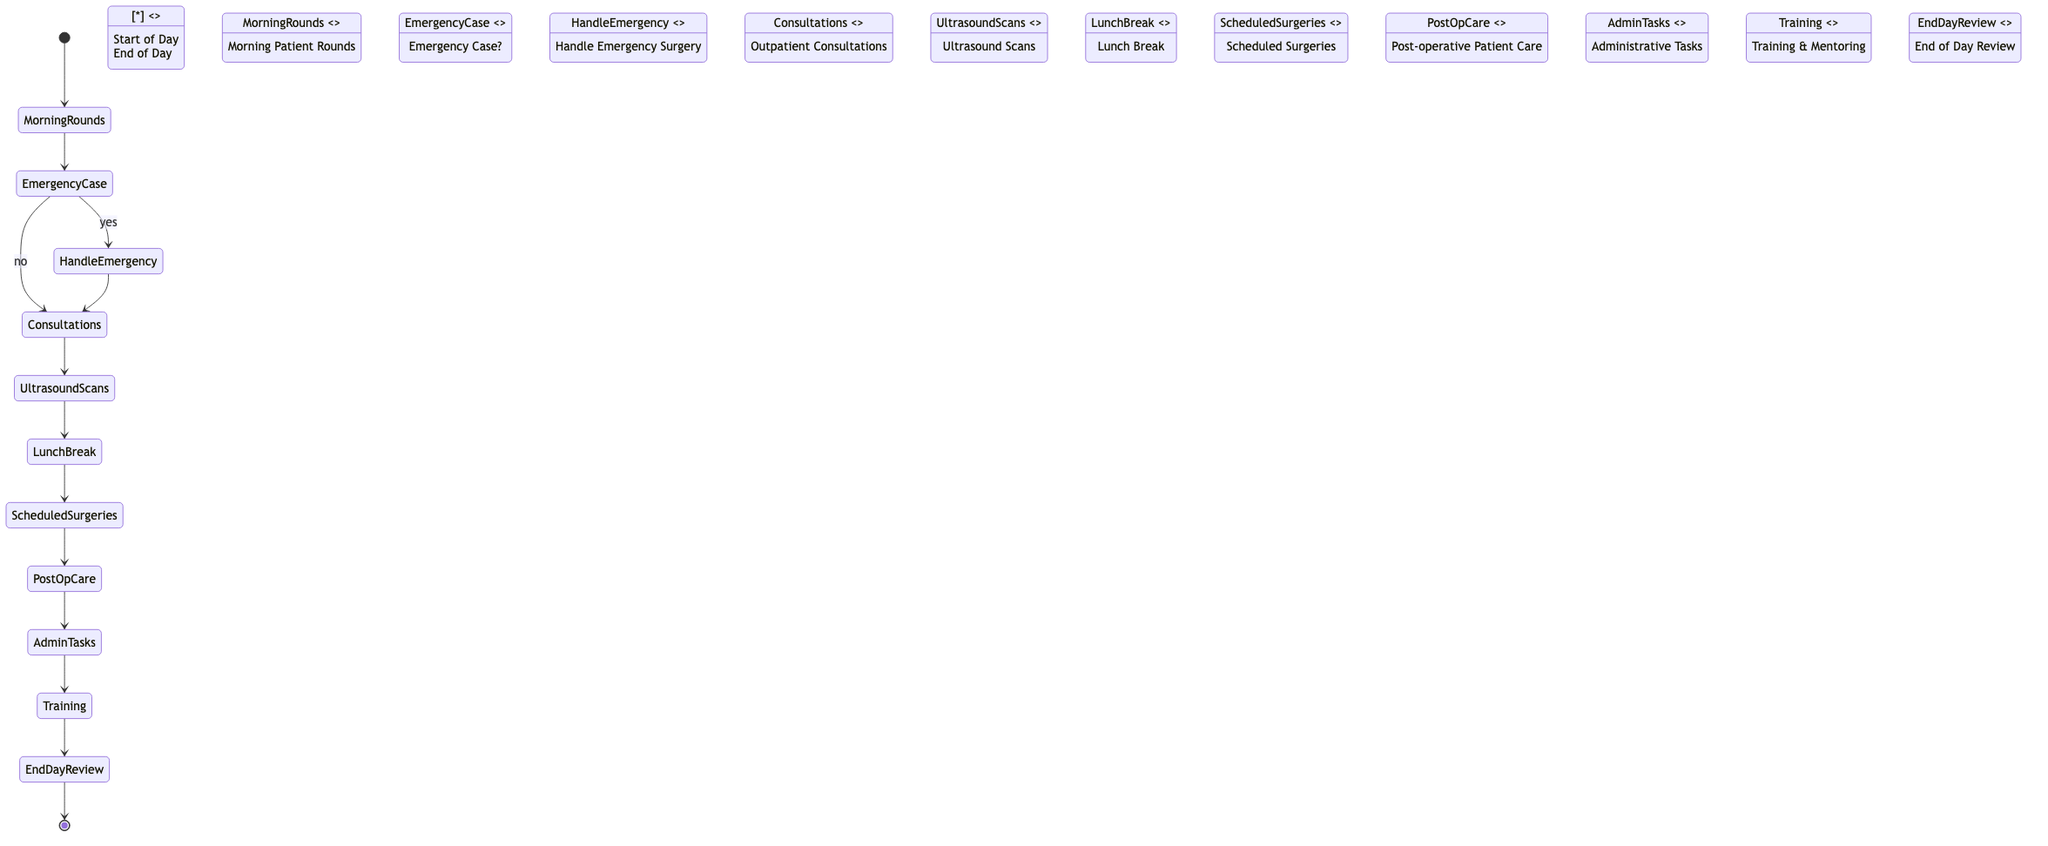What is the first activity in the daily workflow? The first activity is "Morning Patient Rounds," which follows the initial node labeled "Start of Day."
Answer: Morning Patient Rounds How many decision nodes are present in the diagram? There is one decision node labeled "Emergency Case?" that leads to different paths based on the condition.
Answer: 1 What comes after "Lunch Break"? After "Lunch Break," the next activity is "Scheduled Surgeries," as indicated by the flow from one activity to the next.
Answer: Scheduled Surgeries What activity follows "Post-operative Patient Care"? "Administrative Tasks" comes next after "Post-operative Patient Care" in the workflow sequence.
Answer: Administrative Tasks What happens if there is an "Emergency Case"? If there is an "Emergency Case," the workflow path goes to "Handle Emergency Surgery." This is determined by the condition of the decision node.
Answer: Handle Emergency Surgery Which activity occurs after "Scheduled Surgeries"? The activity that occurs after "Scheduled Surgeries" is "Post-operative Patient Care." This follows the flow established in the diagram.
Answer: Post-operative Patient Care What is the last activity before the end of the day? The last activity before reaching the final node "End of Day" is "End of Day Review," which summarizes the day's procedures.
Answer: End of Day Review What activity is performed following "Ultrasound Scans"? Following "Ultrasound Scans," the next activity is "Lunch Break," as indicated in the workflow sequence.
Answer: Lunch Break What role does "Training & Mentoring" play in the workflow? "Training & Mentoring" is an activity that involves conducting training sessions, and it is placed before the "End of Day Review."
Answer: Activity in workflow 